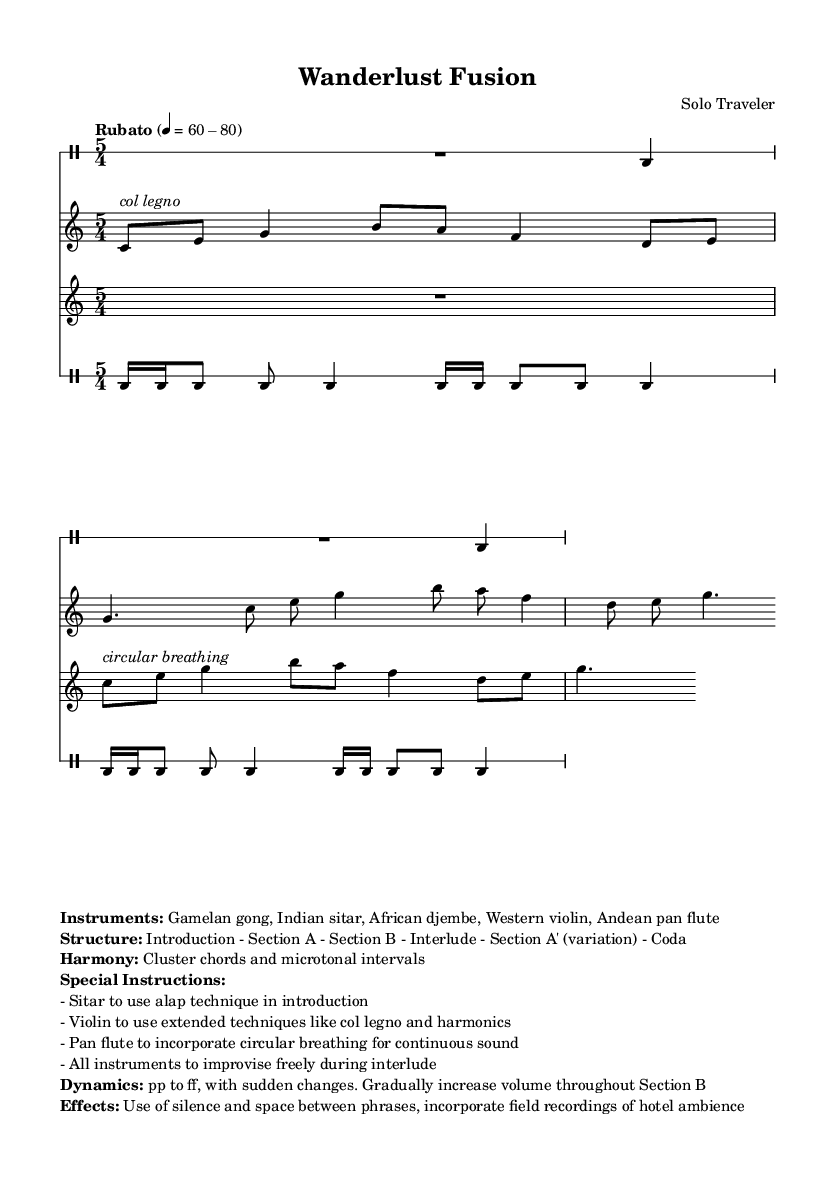What is the time signature of this music? The time signature indicated in the sheet music is 5/4, as shown at the beginning of each staff.
Answer: 5/4 What is the dynamic range indicated in the score? The dynamics range mentioned in the sheet music is from pp to ff, with instructions to gradually increase volume throughout Section B.
Answer: pp to ff How many sections are there in the composition? The structure of the composition is divided into several sections: Introduction, Section A, Section B, Interlude, Section A' (variation), and Coda, which makes a total of six parts.
Answer: Six What technique is specified for the violin in the introduction? The specific technique mentioned for the violin is "col legno," which is indicated by the markup in the sheet music.
Answer: col legno What improvisation instruction applies during the interlude? The instruction for the interlude indicates that all instruments should "improvise freely," which encourages creative expression during that section.
Answer: improvise freely What special effect is suggested to be included in the performance? The special effect mentioned in the music is the incorporation of field recordings of hotel ambience, adding an extra layer of texture to the performance.
Answer: field recordings of hotel ambience What type of chords is utilized in the harmony of this piece? The harmony features cluster chords and microtonal intervals, as outlined in the markup.
Answer: cluster chords and microtonal intervals 